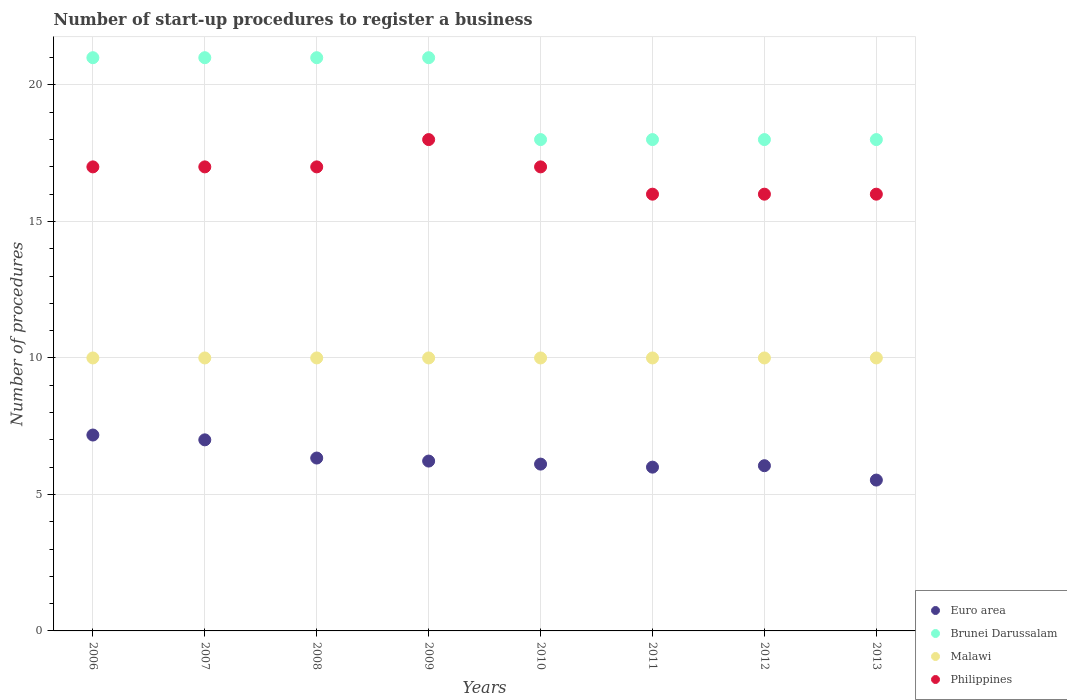Is the number of dotlines equal to the number of legend labels?
Ensure brevity in your answer.  Yes. What is the number of procedures required to register a business in Malawi in 2013?
Provide a short and direct response. 10. Across all years, what is the maximum number of procedures required to register a business in Brunei Darussalam?
Ensure brevity in your answer.  21. Across all years, what is the minimum number of procedures required to register a business in Euro area?
Give a very brief answer. 5.53. What is the total number of procedures required to register a business in Brunei Darussalam in the graph?
Keep it short and to the point. 156. What is the difference between the number of procedures required to register a business in Euro area in 2008 and that in 2011?
Your answer should be compact. 0.33. What is the average number of procedures required to register a business in Euro area per year?
Offer a very short reply. 6.3. In the year 2012, what is the difference between the number of procedures required to register a business in Malawi and number of procedures required to register a business in Brunei Darussalam?
Ensure brevity in your answer.  -8. In how many years, is the number of procedures required to register a business in Malawi greater than 11?
Provide a short and direct response. 0. What is the ratio of the number of procedures required to register a business in Euro area in 2011 to that in 2012?
Provide a succinct answer. 0.99. Is the difference between the number of procedures required to register a business in Malawi in 2007 and 2010 greater than the difference between the number of procedures required to register a business in Brunei Darussalam in 2007 and 2010?
Your response must be concise. No. Is the sum of the number of procedures required to register a business in Euro area in 2006 and 2013 greater than the maximum number of procedures required to register a business in Philippines across all years?
Offer a very short reply. No. Is the number of procedures required to register a business in Brunei Darussalam strictly greater than the number of procedures required to register a business in Malawi over the years?
Ensure brevity in your answer.  Yes. Is the number of procedures required to register a business in Philippines strictly less than the number of procedures required to register a business in Euro area over the years?
Make the answer very short. No. How many years are there in the graph?
Offer a very short reply. 8. Does the graph contain any zero values?
Keep it short and to the point. No. Does the graph contain grids?
Provide a succinct answer. Yes. Where does the legend appear in the graph?
Provide a succinct answer. Bottom right. How many legend labels are there?
Offer a terse response. 4. How are the legend labels stacked?
Give a very brief answer. Vertical. What is the title of the graph?
Offer a terse response. Number of start-up procedures to register a business. What is the label or title of the Y-axis?
Your answer should be very brief. Number of procedures. What is the Number of procedures in Euro area in 2006?
Give a very brief answer. 7.18. What is the Number of procedures of Malawi in 2007?
Provide a succinct answer. 10. What is the Number of procedures of Philippines in 2007?
Give a very brief answer. 17. What is the Number of procedures in Euro area in 2008?
Your response must be concise. 6.33. What is the Number of procedures in Euro area in 2009?
Your answer should be compact. 6.22. What is the Number of procedures of Brunei Darussalam in 2009?
Provide a succinct answer. 21. What is the Number of procedures in Philippines in 2009?
Ensure brevity in your answer.  18. What is the Number of procedures of Euro area in 2010?
Your answer should be very brief. 6.11. What is the Number of procedures in Malawi in 2010?
Provide a succinct answer. 10. What is the Number of procedures of Euro area in 2011?
Provide a succinct answer. 6. What is the Number of procedures in Malawi in 2011?
Keep it short and to the point. 10. What is the Number of procedures of Euro area in 2012?
Your answer should be very brief. 6.05. What is the Number of procedures in Euro area in 2013?
Ensure brevity in your answer.  5.53. What is the Number of procedures in Malawi in 2013?
Make the answer very short. 10. What is the Number of procedures in Philippines in 2013?
Provide a succinct answer. 16. Across all years, what is the maximum Number of procedures in Euro area?
Provide a succinct answer. 7.18. Across all years, what is the maximum Number of procedures in Malawi?
Your answer should be compact. 10. Across all years, what is the maximum Number of procedures of Philippines?
Offer a very short reply. 18. Across all years, what is the minimum Number of procedures in Euro area?
Provide a succinct answer. 5.53. Across all years, what is the minimum Number of procedures in Brunei Darussalam?
Provide a short and direct response. 18. Across all years, what is the minimum Number of procedures of Philippines?
Give a very brief answer. 16. What is the total Number of procedures in Euro area in the graph?
Give a very brief answer. 50.42. What is the total Number of procedures of Brunei Darussalam in the graph?
Keep it short and to the point. 156. What is the total Number of procedures in Philippines in the graph?
Your answer should be very brief. 134. What is the difference between the Number of procedures in Euro area in 2006 and that in 2007?
Offer a very short reply. 0.18. What is the difference between the Number of procedures in Brunei Darussalam in 2006 and that in 2007?
Offer a very short reply. 0. What is the difference between the Number of procedures in Philippines in 2006 and that in 2007?
Your answer should be compact. 0. What is the difference between the Number of procedures in Euro area in 2006 and that in 2008?
Give a very brief answer. 0.84. What is the difference between the Number of procedures in Brunei Darussalam in 2006 and that in 2008?
Give a very brief answer. 0. What is the difference between the Number of procedures of Malawi in 2006 and that in 2008?
Offer a terse response. 0. What is the difference between the Number of procedures in Euro area in 2006 and that in 2009?
Your response must be concise. 0.95. What is the difference between the Number of procedures of Brunei Darussalam in 2006 and that in 2009?
Provide a succinct answer. 0. What is the difference between the Number of procedures in Philippines in 2006 and that in 2009?
Your answer should be compact. -1. What is the difference between the Number of procedures in Euro area in 2006 and that in 2010?
Provide a short and direct response. 1.07. What is the difference between the Number of procedures of Brunei Darussalam in 2006 and that in 2010?
Ensure brevity in your answer.  3. What is the difference between the Number of procedures of Malawi in 2006 and that in 2010?
Keep it short and to the point. 0. What is the difference between the Number of procedures of Euro area in 2006 and that in 2011?
Provide a short and direct response. 1.18. What is the difference between the Number of procedures of Philippines in 2006 and that in 2011?
Make the answer very short. 1. What is the difference between the Number of procedures of Euro area in 2006 and that in 2012?
Your answer should be compact. 1.12. What is the difference between the Number of procedures in Philippines in 2006 and that in 2012?
Keep it short and to the point. 1. What is the difference between the Number of procedures of Euro area in 2006 and that in 2013?
Give a very brief answer. 1.65. What is the difference between the Number of procedures of Brunei Darussalam in 2006 and that in 2013?
Your answer should be compact. 3. What is the difference between the Number of procedures in Malawi in 2006 and that in 2013?
Your response must be concise. 0. What is the difference between the Number of procedures of Philippines in 2006 and that in 2013?
Provide a short and direct response. 1. What is the difference between the Number of procedures of Euro area in 2007 and that in 2008?
Your answer should be very brief. 0.67. What is the difference between the Number of procedures in Malawi in 2007 and that in 2008?
Your answer should be compact. 0. What is the difference between the Number of procedures in Philippines in 2007 and that in 2008?
Offer a terse response. 0. What is the difference between the Number of procedures in Philippines in 2007 and that in 2009?
Offer a terse response. -1. What is the difference between the Number of procedures of Euro area in 2007 and that in 2010?
Keep it short and to the point. 0.89. What is the difference between the Number of procedures of Brunei Darussalam in 2007 and that in 2010?
Your answer should be compact. 3. What is the difference between the Number of procedures of Malawi in 2007 and that in 2010?
Your answer should be compact. 0. What is the difference between the Number of procedures of Philippines in 2007 and that in 2010?
Your response must be concise. 0. What is the difference between the Number of procedures in Euro area in 2007 and that in 2011?
Your answer should be compact. 1. What is the difference between the Number of procedures of Brunei Darussalam in 2007 and that in 2011?
Provide a succinct answer. 3. What is the difference between the Number of procedures of Philippines in 2007 and that in 2011?
Offer a very short reply. 1. What is the difference between the Number of procedures in Euro area in 2007 and that in 2012?
Provide a succinct answer. 0.95. What is the difference between the Number of procedures in Philippines in 2007 and that in 2012?
Offer a terse response. 1. What is the difference between the Number of procedures in Euro area in 2007 and that in 2013?
Offer a very short reply. 1.47. What is the difference between the Number of procedures of Brunei Darussalam in 2007 and that in 2013?
Provide a succinct answer. 3. What is the difference between the Number of procedures in Malawi in 2007 and that in 2013?
Make the answer very short. 0. What is the difference between the Number of procedures in Brunei Darussalam in 2008 and that in 2009?
Provide a succinct answer. 0. What is the difference between the Number of procedures of Euro area in 2008 and that in 2010?
Give a very brief answer. 0.22. What is the difference between the Number of procedures in Brunei Darussalam in 2008 and that in 2010?
Your response must be concise. 3. What is the difference between the Number of procedures in Malawi in 2008 and that in 2010?
Offer a very short reply. 0. What is the difference between the Number of procedures in Euro area in 2008 and that in 2011?
Offer a very short reply. 0.33. What is the difference between the Number of procedures in Brunei Darussalam in 2008 and that in 2011?
Ensure brevity in your answer.  3. What is the difference between the Number of procedures of Philippines in 2008 and that in 2011?
Provide a short and direct response. 1. What is the difference between the Number of procedures of Euro area in 2008 and that in 2012?
Your answer should be compact. 0.28. What is the difference between the Number of procedures in Euro area in 2008 and that in 2013?
Ensure brevity in your answer.  0.81. What is the difference between the Number of procedures in Brunei Darussalam in 2008 and that in 2013?
Offer a terse response. 3. What is the difference between the Number of procedures of Malawi in 2008 and that in 2013?
Make the answer very short. 0. What is the difference between the Number of procedures in Euro area in 2009 and that in 2010?
Provide a succinct answer. 0.11. What is the difference between the Number of procedures of Brunei Darussalam in 2009 and that in 2010?
Keep it short and to the point. 3. What is the difference between the Number of procedures in Philippines in 2009 and that in 2010?
Your response must be concise. 1. What is the difference between the Number of procedures of Euro area in 2009 and that in 2011?
Ensure brevity in your answer.  0.22. What is the difference between the Number of procedures in Brunei Darussalam in 2009 and that in 2011?
Give a very brief answer. 3. What is the difference between the Number of procedures of Philippines in 2009 and that in 2011?
Offer a terse response. 2. What is the difference between the Number of procedures in Euro area in 2009 and that in 2012?
Keep it short and to the point. 0.17. What is the difference between the Number of procedures in Malawi in 2009 and that in 2012?
Your answer should be very brief. 0. What is the difference between the Number of procedures of Philippines in 2009 and that in 2012?
Keep it short and to the point. 2. What is the difference between the Number of procedures of Euro area in 2009 and that in 2013?
Offer a terse response. 0.7. What is the difference between the Number of procedures in Philippines in 2009 and that in 2013?
Your answer should be very brief. 2. What is the difference between the Number of procedures in Euro area in 2010 and that in 2011?
Offer a very short reply. 0.11. What is the difference between the Number of procedures in Malawi in 2010 and that in 2011?
Give a very brief answer. 0. What is the difference between the Number of procedures in Euro area in 2010 and that in 2012?
Offer a very short reply. 0.06. What is the difference between the Number of procedures in Brunei Darussalam in 2010 and that in 2012?
Your answer should be very brief. 0. What is the difference between the Number of procedures of Philippines in 2010 and that in 2012?
Make the answer very short. 1. What is the difference between the Number of procedures of Euro area in 2010 and that in 2013?
Provide a succinct answer. 0.58. What is the difference between the Number of procedures of Philippines in 2010 and that in 2013?
Your answer should be very brief. 1. What is the difference between the Number of procedures of Euro area in 2011 and that in 2012?
Give a very brief answer. -0.05. What is the difference between the Number of procedures of Brunei Darussalam in 2011 and that in 2012?
Provide a short and direct response. 0. What is the difference between the Number of procedures in Philippines in 2011 and that in 2012?
Your answer should be very brief. 0. What is the difference between the Number of procedures in Euro area in 2011 and that in 2013?
Offer a terse response. 0.47. What is the difference between the Number of procedures of Brunei Darussalam in 2011 and that in 2013?
Keep it short and to the point. 0. What is the difference between the Number of procedures of Euro area in 2012 and that in 2013?
Give a very brief answer. 0.53. What is the difference between the Number of procedures of Brunei Darussalam in 2012 and that in 2013?
Keep it short and to the point. 0. What is the difference between the Number of procedures in Malawi in 2012 and that in 2013?
Keep it short and to the point. 0. What is the difference between the Number of procedures in Euro area in 2006 and the Number of procedures in Brunei Darussalam in 2007?
Keep it short and to the point. -13.82. What is the difference between the Number of procedures of Euro area in 2006 and the Number of procedures of Malawi in 2007?
Your answer should be very brief. -2.82. What is the difference between the Number of procedures of Euro area in 2006 and the Number of procedures of Philippines in 2007?
Your answer should be very brief. -9.82. What is the difference between the Number of procedures of Brunei Darussalam in 2006 and the Number of procedures of Philippines in 2007?
Ensure brevity in your answer.  4. What is the difference between the Number of procedures of Malawi in 2006 and the Number of procedures of Philippines in 2007?
Your answer should be very brief. -7. What is the difference between the Number of procedures in Euro area in 2006 and the Number of procedures in Brunei Darussalam in 2008?
Your answer should be very brief. -13.82. What is the difference between the Number of procedures in Euro area in 2006 and the Number of procedures in Malawi in 2008?
Offer a terse response. -2.82. What is the difference between the Number of procedures in Euro area in 2006 and the Number of procedures in Philippines in 2008?
Offer a terse response. -9.82. What is the difference between the Number of procedures in Brunei Darussalam in 2006 and the Number of procedures in Malawi in 2008?
Offer a very short reply. 11. What is the difference between the Number of procedures in Malawi in 2006 and the Number of procedures in Philippines in 2008?
Give a very brief answer. -7. What is the difference between the Number of procedures in Euro area in 2006 and the Number of procedures in Brunei Darussalam in 2009?
Offer a very short reply. -13.82. What is the difference between the Number of procedures of Euro area in 2006 and the Number of procedures of Malawi in 2009?
Your answer should be very brief. -2.82. What is the difference between the Number of procedures of Euro area in 2006 and the Number of procedures of Philippines in 2009?
Keep it short and to the point. -10.82. What is the difference between the Number of procedures in Brunei Darussalam in 2006 and the Number of procedures in Malawi in 2009?
Give a very brief answer. 11. What is the difference between the Number of procedures of Malawi in 2006 and the Number of procedures of Philippines in 2009?
Your answer should be very brief. -8. What is the difference between the Number of procedures in Euro area in 2006 and the Number of procedures in Brunei Darussalam in 2010?
Offer a very short reply. -10.82. What is the difference between the Number of procedures of Euro area in 2006 and the Number of procedures of Malawi in 2010?
Your response must be concise. -2.82. What is the difference between the Number of procedures of Euro area in 2006 and the Number of procedures of Philippines in 2010?
Offer a terse response. -9.82. What is the difference between the Number of procedures of Brunei Darussalam in 2006 and the Number of procedures of Philippines in 2010?
Ensure brevity in your answer.  4. What is the difference between the Number of procedures of Euro area in 2006 and the Number of procedures of Brunei Darussalam in 2011?
Keep it short and to the point. -10.82. What is the difference between the Number of procedures of Euro area in 2006 and the Number of procedures of Malawi in 2011?
Keep it short and to the point. -2.82. What is the difference between the Number of procedures of Euro area in 2006 and the Number of procedures of Philippines in 2011?
Ensure brevity in your answer.  -8.82. What is the difference between the Number of procedures of Malawi in 2006 and the Number of procedures of Philippines in 2011?
Provide a short and direct response. -6. What is the difference between the Number of procedures of Euro area in 2006 and the Number of procedures of Brunei Darussalam in 2012?
Keep it short and to the point. -10.82. What is the difference between the Number of procedures in Euro area in 2006 and the Number of procedures in Malawi in 2012?
Give a very brief answer. -2.82. What is the difference between the Number of procedures in Euro area in 2006 and the Number of procedures in Philippines in 2012?
Provide a short and direct response. -8.82. What is the difference between the Number of procedures of Brunei Darussalam in 2006 and the Number of procedures of Malawi in 2012?
Provide a succinct answer. 11. What is the difference between the Number of procedures of Euro area in 2006 and the Number of procedures of Brunei Darussalam in 2013?
Your response must be concise. -10.82. What is the difference between the Number of procedures of Euro area in 2006 and the Number of procedures of Malawi in 2013?
Make the answer very short. -2.82. What is the difference between the Number of procedures of Euro area in 2006 and the Number of procedures of Philippines in 2013?
Your answer should be very brief. -8.82. What is the difference between the Number of procedures of Malawi in 2006 and the Number of procedures of Philippines in 2013?
Your answer should be compact. -6. What is the difference between the Number of procedures of Euro area in 2007 and the Number of procedures of Malawi in 2008?
Your answer should be very brief. -3. What is the difference between the Number of procedures of Euro area in 2007 and the Number of procedures of Philippines in 2008?
Make the answer very short. -10. What is the difference between the Number of procedures in Brunei Darussalam in 2007 and the Number of procedures in Malawi in 2008?
Give a very brief answer. 11. What is the difference between the Number of procedures in Brunei Darussalam in 2007 and the Number of procedures in Philippines in 2008?
Your answer should be very brief. 4. What is the difference between the Number of procedures of Malawi in 2007 and the Number of procedures of Philippines in 2008?
Offer a very short reply. -7. What is the difference between the Number of procedures in Euro area in 2007 and the Number of procedures in Malawi in 2009?
Ensure brevity in your answer.  -3. What is the difference between the Number of procedures in Brunei Darussalam in 2007 and the Number of procedures in Philippines in 2009?
Give a very brief answer. 3. What is the difference between the Number of procedures of Malawi in 2007 and the Number of procedures of Philippines in 2009?
Ensure brevity in your answer.  -8. What is the difference between the Number of procedures in Euro area in 2007 and the Number of procedures in Brunei Darussalam in 2010?
Ensure brevity in your answer.  -11. What is the difference between the Number of procedures of Euro area in 2007 and the Number of procedures of Malawi in 2010?
Your answer should be very brief. -3. What is the difference between the Number of procedures in Euro area in 2007 and the Number of procedures in Philippines in 2010?
Make the answer very short. -10. What is the difference between the Number of procedures of Brunei Darussalam in 2007 and the Number of procedures of Malawi in 2010?
Your answer should be very brief. 11. What is the difference between the Number of procedures in Brunei Darussalam in 2007 and the Number of procedures in Philippines in 2010?
Your answer should be compact. 4. What is the difference between the Number of procedures in Malawi in 2007 and the Number of procedures in Philippines in 2010?
Ensure brevity in your answer.  -7. What is the difference between the Number of procedures of Euro area in 2007 and the Number of procedures of Brunei Darussalam in 2011?
Your answer should be very brief. -11. What is the difference between the Number of procedures in Euro area in 2007 and the Number of procedures in Malawi in 2011?
Provide a short and direct response. -3. What is the difference between the Number of procedures in Euro area in 2007 and the Number of procedures in Philippines in 2011?
Your answer should be very brief. -9. What is the difference between the Number of procedures of Brunei Darussalam in 2007 and the Number of procedures of Malawi in 2011?
Your answer should be very brief. 11. What is the difference between the Number of procedures in Malawi in 2007 and the Number of procedures in Philippines in 2011?
Your answer should be compact. -6. What is the difference between the Number of procedures of Euro area in 2007 and the Number of procedures of Brunei Darussalam in 2012?
Your response must be concise. -11. What is the difference between the Number of procedures of Euro area in 2007 and the Number of procedures of Malawi in 2012?
Provide a short and direct response. -3. What is the difference between the Number of procedures of Euro area in 2007 and the Number of procedures of Philippines in 2012?
Give a very brief answer. -9. What is the difference between the Number of procedures in Brunei Darussalam in 2007 and the Number of procedures in Malawi in 2012?
Keep it short and to the point. 11. What is the difference between the Number of procedures of Euro area in 2007 and the Number of procedures of Brunei Darussalam in 2013?
Your answer should be compact. -11. What is the difference between the Number of procedures in Euro area in 2007 and the Number of procedures in Malawi in 2013?
Ensure brevity in your answer.  -3. What is the difference between the Number of procedures in Brunei Darussalam in 2007 and the Number of procedures in Malawi in 2013?
Offer a terse response. 11. What is the difference between the Number of procedures in Brunei Darussalam in 2007 and the Number of procedures in Philippines in 2013?
Offer a terse response. 5. What is the difference between the Number of procedures of Malawi in 2007 and the Number of procedures of Philippines in 2013?
Offer a terse response. -6. What is the difference between the Number of procedures of Euro area in 2008 and the Number of procedures of Brunei Darussalam in 2009?
Offer a very short reply. -14.67. What is the difference between the Number of procedures of Euro area in 2008 and the Number of procedures of Malawi in 2009?
Offer a very short reply. -3.67. What is the difference between the Number of procedures of Euro area in 2008 and the Number of procedures of Philippines in 2009?
Offer a very short reply. -11.67. What is the difference between the Number of procedures in Brunei Darussalam in 2008 and the Number of procedures in Malawi in 2009?
Offer a terse response. 11. What is the difference between the Number of procedures of Brunei Darussalam in 2008 and the Number of procedures of Philippines in 2009?
Provide a short and direct response. 3. What is the difference between the Number of procedures in Euro area in 2008 and the Number of procedures in Brunei Darussalam in 2010?
Your answer should be compact. -11.67. What is the difference between the Number of procedures in Euro area in 2008 and the Number of procedures in Malawi in 2010?
Offer a very short reply. -3.67. What is the difference between the Number of procedures in Euro area in 2008 and the Number of procedures in Philippines in 2010?
Your answer should be very brief. -10.67. What is the difference between the Number of procedures of Brunei Darussalam in 2008 and the Number of procedures of Malawi in 2010?
Keep it short and to the point. 11. What is the difference between the Number of procedures of Malawi in 2008 and the Number of procedures of Philippines in 2010?
Give a very brief answer. -7. What is the difference between the Number of procedures in Euro area in 2008 and the Number of procedures in Brunei Darussalam in 2011?
Your answer should be compact. -11.67. What is the difference between the Number of procedures of Euro area in 2008 and the Number of procedures of Malawi in 2011?
Your response must be concise. -3.67. What is the difference between the Number of procedures in Euro area in 2008 and the Number of procedures in Philippines in 2011?
Offer a terse response. -9.67. What is the difference between the Number of procedures of Brunei Darussalam in 2008 and the Number of procedures of Malawi in 2011?
Your answer should be compact. 11. What is the difference between the Number of procedures of Malawi in 2008 and the Number of procedures of Philippines in 2011?
Your response must be concise. -6. What is the difference between the Number of procedures in Euro area in 2008 and the Number of procedures in Brunei Darussalam in 2012?
Provide a succinct answer. -11.67. What is the difference between the Number of procedures in Euro area in 2008 and the Number of procedures in Malawi in 2012?
Provide a short and direct response. -3.67. What is the difference between the Number of procedures of Euro area in 2008 and the Number of procedures of Philippines in 2012?
Make the answer very short. -9.67. What is the difference between the Number of procedures of Brunei Darussalam in 2008 and the Number of procedures of Malawi in 2012?
Your answer should be very brief. 11. What is the difference between the Number of procedures in Euro area in 2008 and the Number of procedures in Brunei Darussalam in 2013?
Make the answer very short. -11.67. What is the difference between the Number of procedures of Euro area in 2008 and the Number of procedures of Malawi in 2013?
Your answer should be compact. -3.67. What is the difference between the Number of procedures of Euro area in 2008 and the Number of procedures of Philippines in 2013?
Your answer should be compact. -9.67. What is the difference between the Number of procedures of Brunei Darussalam in 2008 and the Number of procedures of Malawi in 2013?
Ensure brevity in your answer.  11. What is the difference between the Number of procedures in Brunei Darussalam in 2008 and the Number of procedures in Philippines in 2013?
Your response must be concise. 5. What is the difference between the Number of procedures of Euro area in 2009 and the Number of procedures of Brunei Darussalam in 2010?
Your answer should be compact. -11.78. What is the difference between the Number of procedures in Euro area in 2009 and the Number of procedures in Malawi in 2010?
Keep it short and to the point. -3.78. What is the difference between the Number of procedures of Euro area in 2009 and the Number of procedures of Philippines in 2010?
Provide a succinct answer. -10.78. What is the difference between the Number of procedures of Euro area in 2009 and the Number of procedures of Brunei Darussalam in 2011?
Your answer should be compact. -11.78. What is the difference between the Number of procedures of Euro area in 2009 and the Number of procedures of Malawi in 2011?
Your answer should be very brief. -3.78. What is the difference between the Number of procedures in Euro area in 2009 and the Number of procedures in Philippines in 2011?
Ensure brevity in your answer.  -9.78. What is the difference between the Number of procedures in Malawi in 2009 and the Number of procedures in Philippines in 2011?
Make the answer very short. -6. What is the difference between the Number of procedures of Euro area in 2009 and the Number of procedures of Brunei Darussalam in 2012?
Your answer should be compact. -11.78. What is the difference between the Number of procedures in Euro area in 2009 and the Number of procedures in Malawi in 2012?
Give a very brief answer. -3.78. What is the difference between the Number of procedures in Euro area in 2009 and the Number of procedures in Philippines in 2012?
Provide a succinct answer. -9.78. What is the difference between the Number of procedures of Brunei Darussalam in 2009 and the Number of procedures of Malawi in 2012?
Give a very brief answer. 11. What is the difference between the Number of procedures of Brunei Darussalam in 2009 and the Number of procedures of Philippines in 2012?
Provide a short and direct response. 5. What is the difference between the Number of procedures of Malawi in 2009 and the Number of procedures of Philippines in 2012?
Your answer should be compact. -6. What is the difference between the Number of procedures of Euro area in 2009 and the Number of procedures of Brunei Darussalam in 2013?
Your answer should be very brief. -11.78. What is the difference between the Number of procedures in Euro area in 2009 and the Number of procedures in Malawi in 2013?
Keep it short and to the point. -3.78. What is the difference between the Number of procedures in Euro area in 2009 and the Number of procedures in Philippines in 2013?
Make the answer very short. -9.78. What is the difference between the Number of procedures in Brunei Darussalam in 2009 and the Number of procedures in Philippines in 2013?
Keep it short and to the point. 5. What is the difference between the Number of procedures of Malawi in 2009 and the Number of procedures of Philippines in 2013?
Make the answer very short. -6. What is the difference between the Number of procedures in Euro area in 2010 and the Number of procedures in Brunei Darussalam in 2011?
Keep it short and to the point. -11.89. What is the difference between the Number of procedures in Euro area in 2010 and the Number of procedures in Malawi in 2011?
Ensure brevity in your answer.  -3.89. What is the difference between the Number of procedures of Euro area in 2010 and the Number of procedures of Philippines in 2011?
Ensure brevity in your answer.  -9.89. What is the difference between the Number of procedures in Malawi in 2010 and the Number of procedures in Philippines in 2011?
Offer a terse response. -6. What is the difference between the Number of procedures in Euro area in 2010 and the Number of procedures in Brunei Darussalam in 2012?
Keep it short and to the point. -11.89. What is the difference between the Number of procedures in Euro area in 2010 and the Number of procedures in Malawi in 2012?
Give a very brief answer. -3.89. What is the difference between the Number of procedures in Euro area in 2010 and the Number of procedures in Philippines in 2012?
Your answer should be compact. -9.89. What is the difference between the Number of procedures in Euro area in 2010 and the Number of procedures in Brunei Darussalam in 2013?
Make the answer very short. -11.89. What is the difference between the Number of procedures of Euro area in 2010 and the Number of procedures of Malawi in 2013?
Your answer should be compact. -3.89. What is the difference between the Number of procedures in Euro area in 2010 and the Number of procedures in Philippines in 2013?
Offer a terse response. -9.89. What is the difference between the Number of procedures in Brunei Darussalam in 2010 and the Number of procedures in Malawi in 2013?
Offer a terse response. 8. What is the difference between the Number of procedures in Euro area in 2011 and the Number of procedures in Brunei Darussalam in 2013?
Give a very brief answer. -12. What is the difference between the Number of procedures of Malawi in 2011 and the Number of procedures of Philippines in 2013?
Your response must be concise. -6. What is the difference between the Number of procedures of Euro area in 2012 and the Number of procedures of Brunei Darussalam in 2013?
Keep it short and to the point. -11.95. What is the difference between the Number of procedures of Euro area in 2012 and the Number of procedures of Malawi in 2013?
Provide a succinct answer. -3.95. What is the difference between the Number of procedures of Euro area in 2012 and the Number of procedures of Philippines in 2013?
Your answer should be very brief. -9.95. What is the average Number of procedures of Euro area per year?
Your answer should be very brief. 6.3. What is the average Number of procedures in Brunei Darussalam per year?
Give a very brief answer. 19.5. What is the average Number of procedures of Malawi per year?
Provide a short and direct response. 10. What is the average Number of procedures of Philippines per year?
Your answer should be compact. 16.75. In the year 2006, what is the difference between the Number of procedures of Euro area and Number of procedures of Brunei Darussalam?
Make the answer very short. -13.82. In the year 2006, what is the difference between the Number of procedures of Euro area and Number of procedures of Malawi?
Ensure brevity in your answer.  -2.82. In the year 2006, what is the difference between the Number of procedures in Euro area and Number of procedures in Philippines?
Ensure brevity in your answer.  -9.82. In the year 2006, what is the difference between the Number of procedures in Brunei Darussalam and Number of procedures in Malawi?
Your answer should be compact. 11. In the year 2007, what is the difference between the Number of procedures in Euro area and Number of procedures in Philippines?
Provide a short and direct response. -10. In the year 2007, what is the difference between the Number of procedures of Brunei Darussalam and Number of procedures of Malawi?
Offer a very short reply. 11. In the year 2007, what is the difference between the Number of procedures in Malawi and Number of procedures in Philippines?
Make the answer very short. -7. In the year 2008, what is the difference between the Number of procedures in Euro area and Number of procedures in Brunei Darussalam?
Provide a succinct answer. -14.67. In the year 2008, what is the difference between the Number of procedures in Euro area and Number of procedures in Malawi?
Ensure brevity in your answer.  -3.67. In the year 2008, what is the difference between the Number of procedures of Euro area and Number of procedures of Philippines?
Ensure brevity in your answer.  -10.67. In the year 2008, what is the difference between the Number of procedures of Brunei Darussalam and Number of procedures of Malawi?
Your answer should be compact. 11. In the year 2009, what is the difference between the Number of procedures of Euro area and Number of procedures of Brunei Darussalam?
Keep it short and to the point. -14.78. In the year 2009, what is the difference between the Number of procedures of Euro area and Number of procedures of Malawi?
Make the answer very short. -3.78. In the year 2009, what is the difference between the Number of procedures in Euro area and Number of procedures in Philippines?
Offer a very short reply. -11.78. In the year 2009, what is the difference between the Number of procedures of Brunei Darussalam and Number of procedures of Malawi?
Make the answer very short. 11. In the year 2009, what is the difference between the Number of procedures of Brunei Darussalam and Number of procedures of Philippines?
Ensure brevity in your answer.  3. In the year 2009, what is the difference between the Number of procedures in Malawi and Number of procedures in Philippines?
Your answer should be very brief. -8. In the year 2010, what is the difference between the Number of procedures in Euro area and Number of procedures in Brunei Darussalam?
Offer a very short reply. -11.89. In the year 2010, what is the difference between the Number of procedures in Euro area and Number of procedures in Malawi?
Keep it short and to the point. -3.89. In the year 2010, what is the difference between the Number of procedures in Euro area and Number of procedures in Philippines?
Your answer should be compact. -10.89. In the year 2010, what is the difference between the Number of procedures of Brunei Darussalam and Number of procedures of Philippines?
Give a very brief answer. 1. In the year 2011, what is the difference between the Number of procedures in Euro area and Number of procedures in Brunei Darussalam?
Provide a short and direct response. -12. In the year 2011, what is the difference between the Number of procedures in Brunei Darussalam and Number of procedures in Malawi?
Provide a short and direct response. 8. In the year 2011, what is the difference between the Number of procedures in Brunei Darussalam and Number of procedures in Philippines?
Provide a succinct answer. 2. In the year 2011, what is the difference between the Number of procedures of Malawi and Number of procedures of Philippines?
Keep it short and to the point. -6. In the year 2012, what is the difference between the Number of procedures in Euro area and Number of procedures in Brunei Darussalam?
Provide a succinct answer. -11.95. In the year 2012, what is the difference between the Number of procedures in Euro area and Number of procedures in Malawi?
Your answer should be compact. -3.95. In the year 2012, what is the difference between the Number of procedures in Euro area and Number of procedures in Philippines?
Your answer should be very brief. -9.95. In the year 2012, what is the difference between the Number of procedures of Brunei Darussalam and Number of procedures of Malawi?
Provide a succinct answer. 8. In the year 2012, what is the difference between the Number of procedures of Malawi and Number of procedures of Philippines?
Make the answer very short. -6. In the year 2013, what is the difference between the Number of procedures of Euro area and Number of procedures of Brunei Darussalam?
Your answer should be compact. -12.47. In the year 2013, what is the difference between the Number of procedures of Euro area and Number of procedures of Malawi?
Your answer should be compact. -4.47. In the year 2013, what is the difference between the Number of procedures in Euro area and Number of procedures in Philippines?
Your response must be concise. -10.47. In the year 2013, what is the difference between the Number of procedures in Brunei Darussalam and Number of procedures in Malawi?
Your answer should be very brief. 8. In the year 2013, what is the difference between the Number of procedures of Brunei Darussalam and Number of procedures of Philippines?
Offer a very short reply. 2. What is the ratio of the Number of procedures of Euro area in 2006 to that in 2007?
Provide a succinct answer. 1.03. What is the ratio of the Number of procedures of Brunei Darussalam in 2006 to that in 2007?
Offer a very short reply. 1. What is the ratio of the Number of procedures of Euro area in 2006 to that in 2008?
Provide a succinct answer. 1.13. What is the ratio of the Number of procedures in Brunei Darussalam in 2006 to that in 2008?
Your answer should be compact. 1. What is the ratio of the Number of procedures of Malawi in 2006 to that in 2008?
Provide a short and direct response. 1. What is the ratio of the Number of procedures in Euro area in 2006 to that in 2009?
Give a very brief answer. 1.15. What is the ratio of the Number of procedures in Euro area in 2006 to that in 2010?
Provide a short and direct response. 1.17. What is the ratio of the Number of procedures in Brunei Darussalam in 2006 to that in 2010?
Your answer should be compact. 1.17. What is the ratio of the Number of procedures of Malawi in 2006 to that in 2010?
Ensure brevity in your answer.  1. What is the ratio of the Number of procedures in Euro area in 2006 to that in 2011?
Offer a very short reply. 1.2. What is the ratio of the Number of procedures in Malawi in 2006 to that in 2011?
Provide a short and direct response. 1. What is the ratio of the Number of procedures in Philippines in 2006 to that in 2011?
Offer a very short reply. 1.06. What is the ratio of the Number of procedures of Euro area in 2006 to that in 2012?
Offer a very short reply. 1.19. What is the ratio of the Number of procedures in Brunei Darussalam in 2006 to that in 2012?
Your response must be concise. 1.17. What is the ratio of the Number of procedures of Philippines in 2006 to that in 2012?
Keep it short and to the point. 1.06. What is the ratio of the Number of procedures in Euro area in 2006 to that in 2013?
Offer a terse response. 1.3. What is the ratio of the Number of procedures in Brunei Darussalam in 2006 to that in 2013?
Offer a terse response. 1.17. What is the ratio of the Number of procedures of Euro area in 2007 to that in 2008?
Provide a short and direct response. 1.11. What is the ratio of the Number of procedures of Malawi in 2007 to that in 2008?
Provide a succinct answer. 1. What is the ratio of the Number of procedures in Philippines in 2007 to that in 2008?
Provide a succinct answer. 1. What is the ratio of the Number of procedures in Euro area in 2007 to that in 2009?
Offer a very short reply. 1.12. What is the ratio of the Number of procedures in Philippines in 2007 to that in 2009?
Ensure brevity in your answer.  0.94. What is the ratio of the Number of procedures in Euro area in 2007 to that in 2010?
Your response must be concise. 1.15. What is the ratio of the Number of procedures in Brunei Darussalam in 2007 to that in 2010?
Provide a short and direct response. 1.17. What is the ratio of the Number of procedures of Malawi in 2007 to that in 2010?
Offer a very short reply. 1. What is the ratio of the Number of procedures of Philippines in 2007 to that in 2010?
Ensure brevity in your answer.  1. What is the ratio of the Number of procedures in Euro area in 2007 to that in 2011?
Offer a terse response. 1.17. What is the ratio of the Number of procedures of Brunei Darussalam in 2007 to that in 2011?
Give a very brief answer. 1.17. What is the ratio of the Number of procedures of Philippines in 2007 to that in 2011?
Provide a succinct answer. 1.06. What is the ratio of the Number of procedures in Euro area in 2007 to that in 2012?
Ensure brevity in your answer.  1.16. What is the ratio of the Number of procedures of Brunei Darussalam in 2007 to that in 2012?
Your answer should be compact. 1.17. What is the ratio of the Number of procedures in Euro area in 2007 to that in 2013?
Your answer should be very brief. 1.27. What is the ratio of the Number of procedures in Brunei Darussalam in 2007 to that in 2013?
Provide a succinct answer. 1.17. What is the ratio of the Number of procedures in Malawi in 2007 to that in 2013?
Give a very brief answer. 1. What is the ratio of the Number of procedures in Philippines in 2007 to that in 2013?
Give a very brief answer. 1.06. What is the ratio of the Number of procedures in Euro area in 2008 to that in 2009?
Make the answer very short. 1.02. What is the ratio of the Number of procedures in Philippines in 2008 to that in 2009?
Make the answer very short. 0.94. What is the ratio of the Number of procedures of Euro area in 2008 to that in 2010?
Keep it short and to the point. 1.04. What is the ratio of the Number of procedures in Brunei Darussalam in 2008 to that in 2010?
Make the answer very short. 1.17. What is the ratio of the Number of procedures of Malawi in 2008 to that in 2010?
Provide a short and direct response. 1. What is the ratio of the Number of procedures in Philippines in 2008 to that in 2010?
Offer a terse response. 1. What is the ratio of the Number of procedures of Euro area in 2008 to that in 2011?
Offer a terse response. 1.06. What is the ratio of the Number of procedures in Brunei Darussalam in 2008 to that in 2011?
Provide a succinct answer. 1.17. What is the ratio of the Number of procedures of Philippines in 2008 to that in 2011?
Your response must be concise. 1.06. What is the ratio of the Number of procedures in Euro area in 2008 to that in 2012?
Your answer should be compact. 1.05. What is the ratio of the Number of procedures in Brunei Darussalam in 2008 to that in 2012?
Offer a terse response. 1.17. What is the ratio of the Number of procedures in Euro area in 2008 to that in 2013?
Offer a terse response. 1.15. What is the ratio of the Number of procedures in Brunei Darussalam in 2008 to that in 2013?
Your answer should be very brief. 1.17. What is the ratio of the Number of procedures in Euro area in 2009 to that in 2010?
Your response must be concise. 1.02. What is the ratio of the Number of procedures of Philippines in 2009 to that in 2010?
Make the answer very short. 1.06. What is the ratio of the Number of procedures in Euro area in 2009 to that in 2011?
Your answer should be very brief. 1.04. What is the ratio of the Number of procedures of Euro area in 2009 to that in 2012?
Your answer should be compact. 1.03. What is the ratio of the Number of procedures in Philippines in 2009 to that in 2012?
Ensure brevity in your answer.  1.12. What is the ratio of the Number of procedures of Euro area in 2009 to that in 2013?
Provide a succinct answer. 1.13. What is the ratio of the Number of procedures of Euro area in 2010 to that in 2011?
Provide a short and direct response. 1.02. What is the ratio of the Number of procedures in Philippines in 2010 to that in 2011?
Provide a short and direct response. 1.06. What is the ratio of the Number of procedures in Euro area in 2010 to that in 2012?
Give a very brief answer. 1.01. What is the ratio of the Number of procedures in Brunei Darussalam in 2010 to that in 2012?
Ensure brevity in your answer.  1. What is the ratio of the Number of procedures of Malawi in 2010 to that in 2012?
Offer a very short reply. 1. What is the ratio of the Number of procedures in Euro area in 2010 to that in 2013?
Your response must be concise. 1.11. What is the ratio of the Number of procedures in Malawi in 2010 to that in 2013?
Provide a succinct answer. 1. What is the ratio of the Number of procedures in Euro area in 2011 to that in 2012?
Keep it short and to the point. 0.99. What is the ratio of the Number of procedures in Brunei Darussalam in 2011 to that in 2012?
Keep it short and to the point. 1. What is the ratio of the Number of procedures of Philippines in 2011 to that in 2012?
Offer a very short reply. 1. What is the ratio of the Number of procedures in Euro area in 2011 to that in 2013?
Your answer should be very brief. 1.09. What is the ratio of the Number of procedures in Malawi in 2011 to that in 2013?
Your answer should be compact. 1. What is the ratio of the Number of procedures of Philippines in 2011 to that in 2013?
Offer a terse response. 1. What is the ratio of the Number of procedures of Euro area in 2012 to that in 2013?
Your answer should be compact. 1.1. What is the ratio of the Number of procedures in Malawi in 2012 to that in 2013?
Your response must be concise. 1. What is the ratio of the Number of procedures in Philippines in 2012 to that in 2013?
Keep it short and to the point. 1. What is the difference between the highest and the second highest Number of procedures in Euro area?
Offer a terse response. 0.18. What is the difference between the highest and the second highest Number of procedures in Malawi?
Provide a succinct answer. 0. What is the difference between the highest and the lowest Number of procedures of Euro area?
Provide a short and direct response. 1.65. What is the difference between the highest and the lowest Number of procedures of Philippines?
Offer a very short reply. 2. 